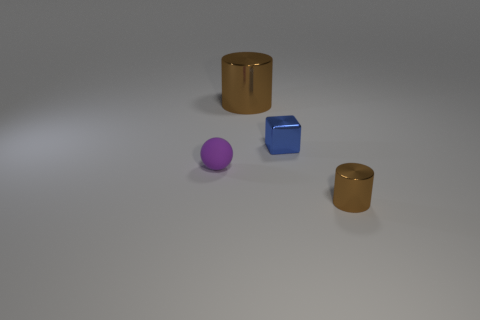Add 2 small brown objects. How many objects exist? 6 Subtract all balls. How many objects are left? 3 Add 2 big brown metal cylinders. How many big brown metal cylinders are left? 3 Add 3 shiny blocks. How many shiny blocks exist? 4 Subtract 1 blue cubes. How many objects are left? 3 Subtract all small brown shiny things. Subtract all brown things. How many objects are left? 1 